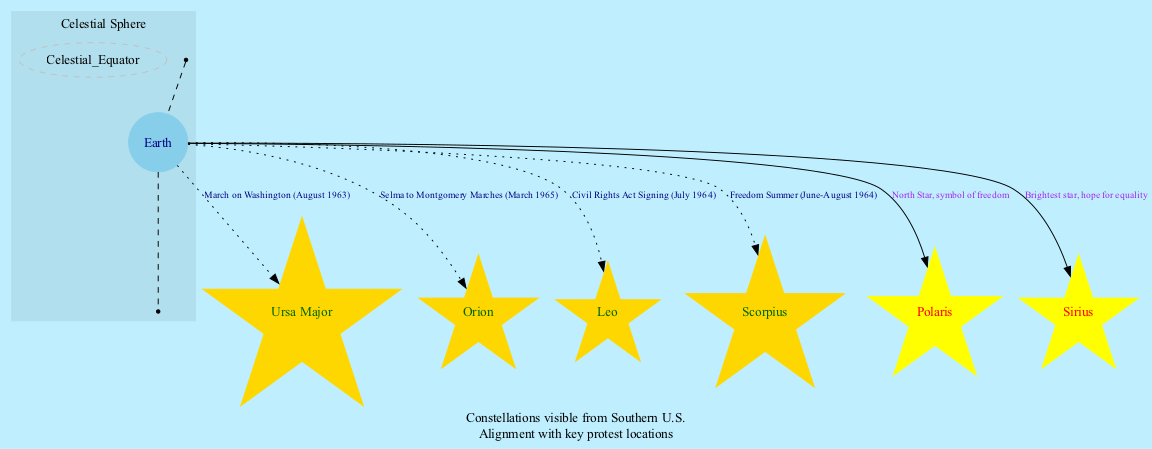What constellation is visible during the March on Washington? The diagram indicates that Ursa Major is associated with the March on Washington, which occurred in August 1963. This information is represented as a connection from Earth to the Ursa Major node labeled "March on Washington (August 1963)".
Answer: Ursa Major How many constellations are shown in the diagram? The diagram includes a total of four constellations: Ursa Major, Orion, Leo, and Scorpius. These are each represented by individual nodes connected to Earth. By counting the nodes, we can determine the number.
Answer: 4 What is the significance of Polaris in the diagram? Polaris is labeled as the North Star on the diagram, and its significance is described as a "symbol of freedom". This connection is visually represented by an edge from Earth to the Polaris node, indicating its important role.
Answer: Symbol of freedom Which event corresponds to the constellation Orion? Orion is indicated to be visible during the Selma to Montgomery Marches, which took place in March 1965. This connection is labeled in the diagram as it connects the Earth node to the Orion node.
Answer: Selma to Montgomery Marches What is the color of the constellation Leo in the diagram? The diagram depicts the constellation Leo using a gold color for its node. This visual representation is consistent across all constellation nodes.
Answer: Gold Which star is described as the brightest in the diagram? The diagram specifies that Sirius is the brightest star, as indicated in its node where the label describes it as such. This is accompanied by an edge connecting it to Earth, highlighting its importance.
Answer: Sirius What annotation is mentioned regarding constellations? The diagram contains annotations that state, "Constellations visible from Southern U.S.," which is positioned at the bottom of the diagram. This information provides context about the visibility of the constellations represented.
Answer: Constellations visible from Southern U.S Which constellation is linked to the Civil Rights Act Signing? The diagram shows that the constellation Leo is linked to the Civil Rights Act Signing that occurred in July 1964. This is visually indicated by the connecting edge labeled appropriately.
Answer: Leo 